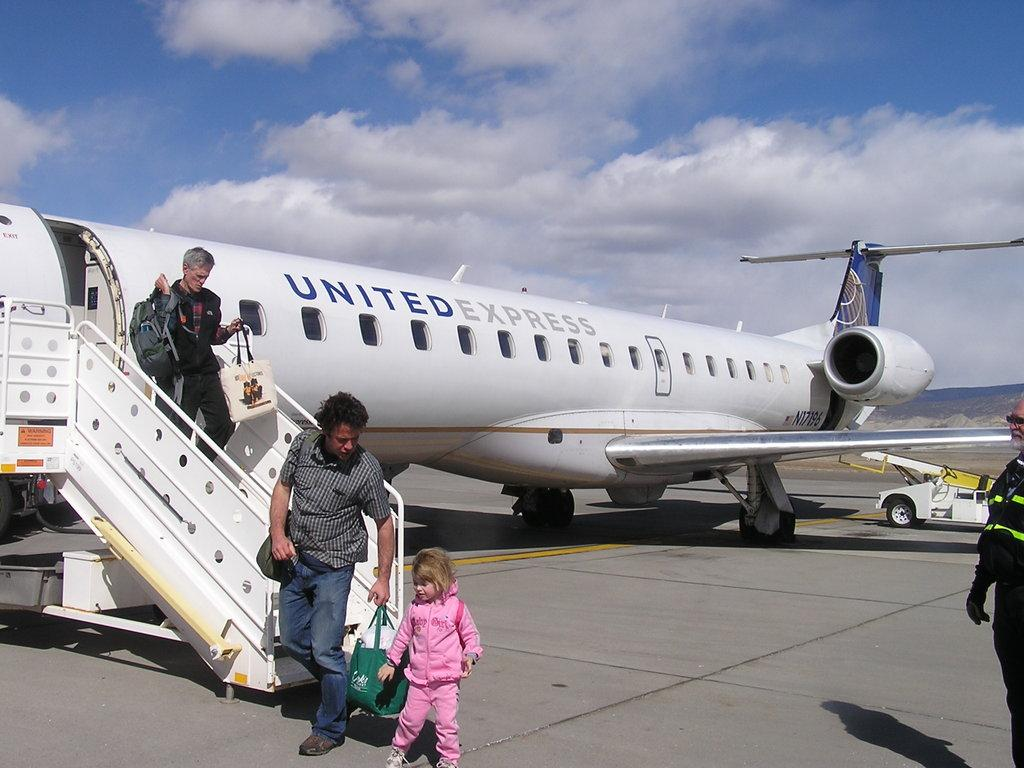<image>
Give a short and clear explanation of the subsequent image. a N17196 UNITED EXPRESS plane where people are leaving from. 